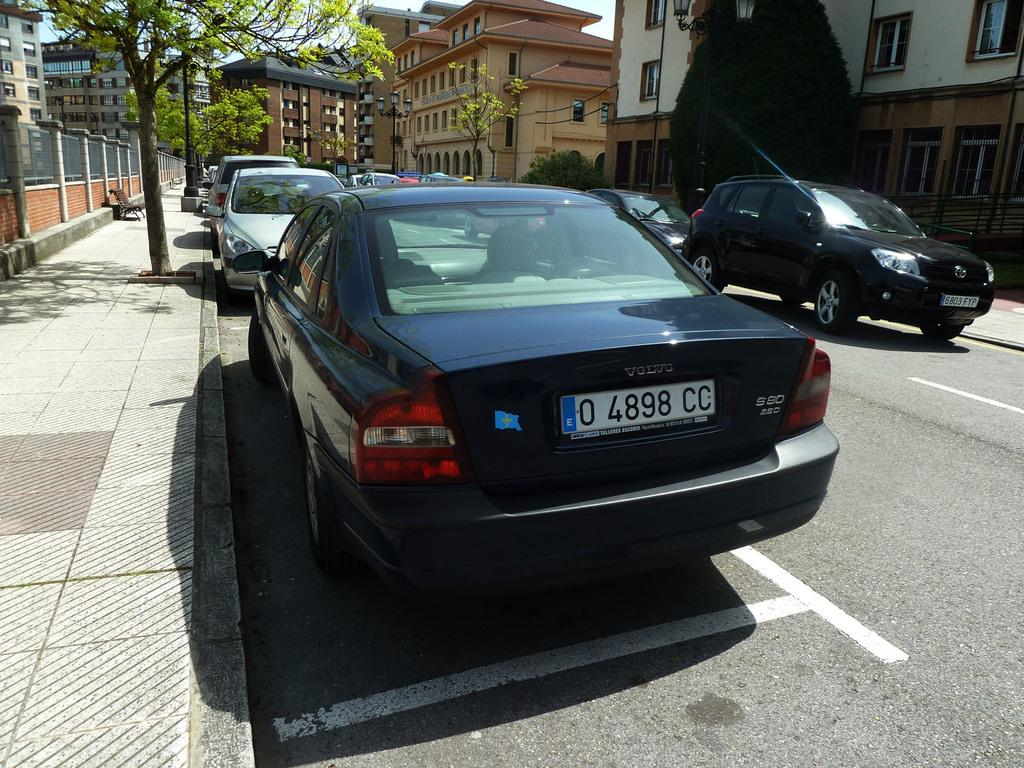<image>
Offer a succinct explanation of the picture presented. A black Volvo sits in a parking spot alongside the curb. 